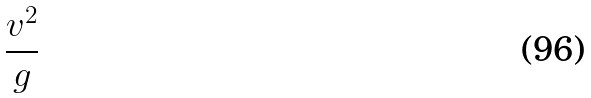<formula> <loc_0><loc_0><loc_500><loc_500>\frac { v ^ { 2 } } { g }</formula> 